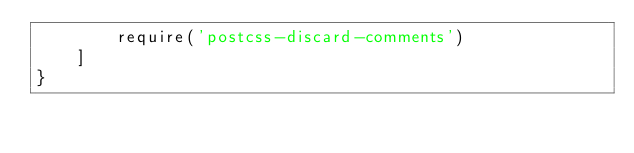Convert code to text. <code><loc_0><loc_0><loc_500><loc_500><_JavaScript_>        require('postcss-discard-comments')
    ]
}
</code> 